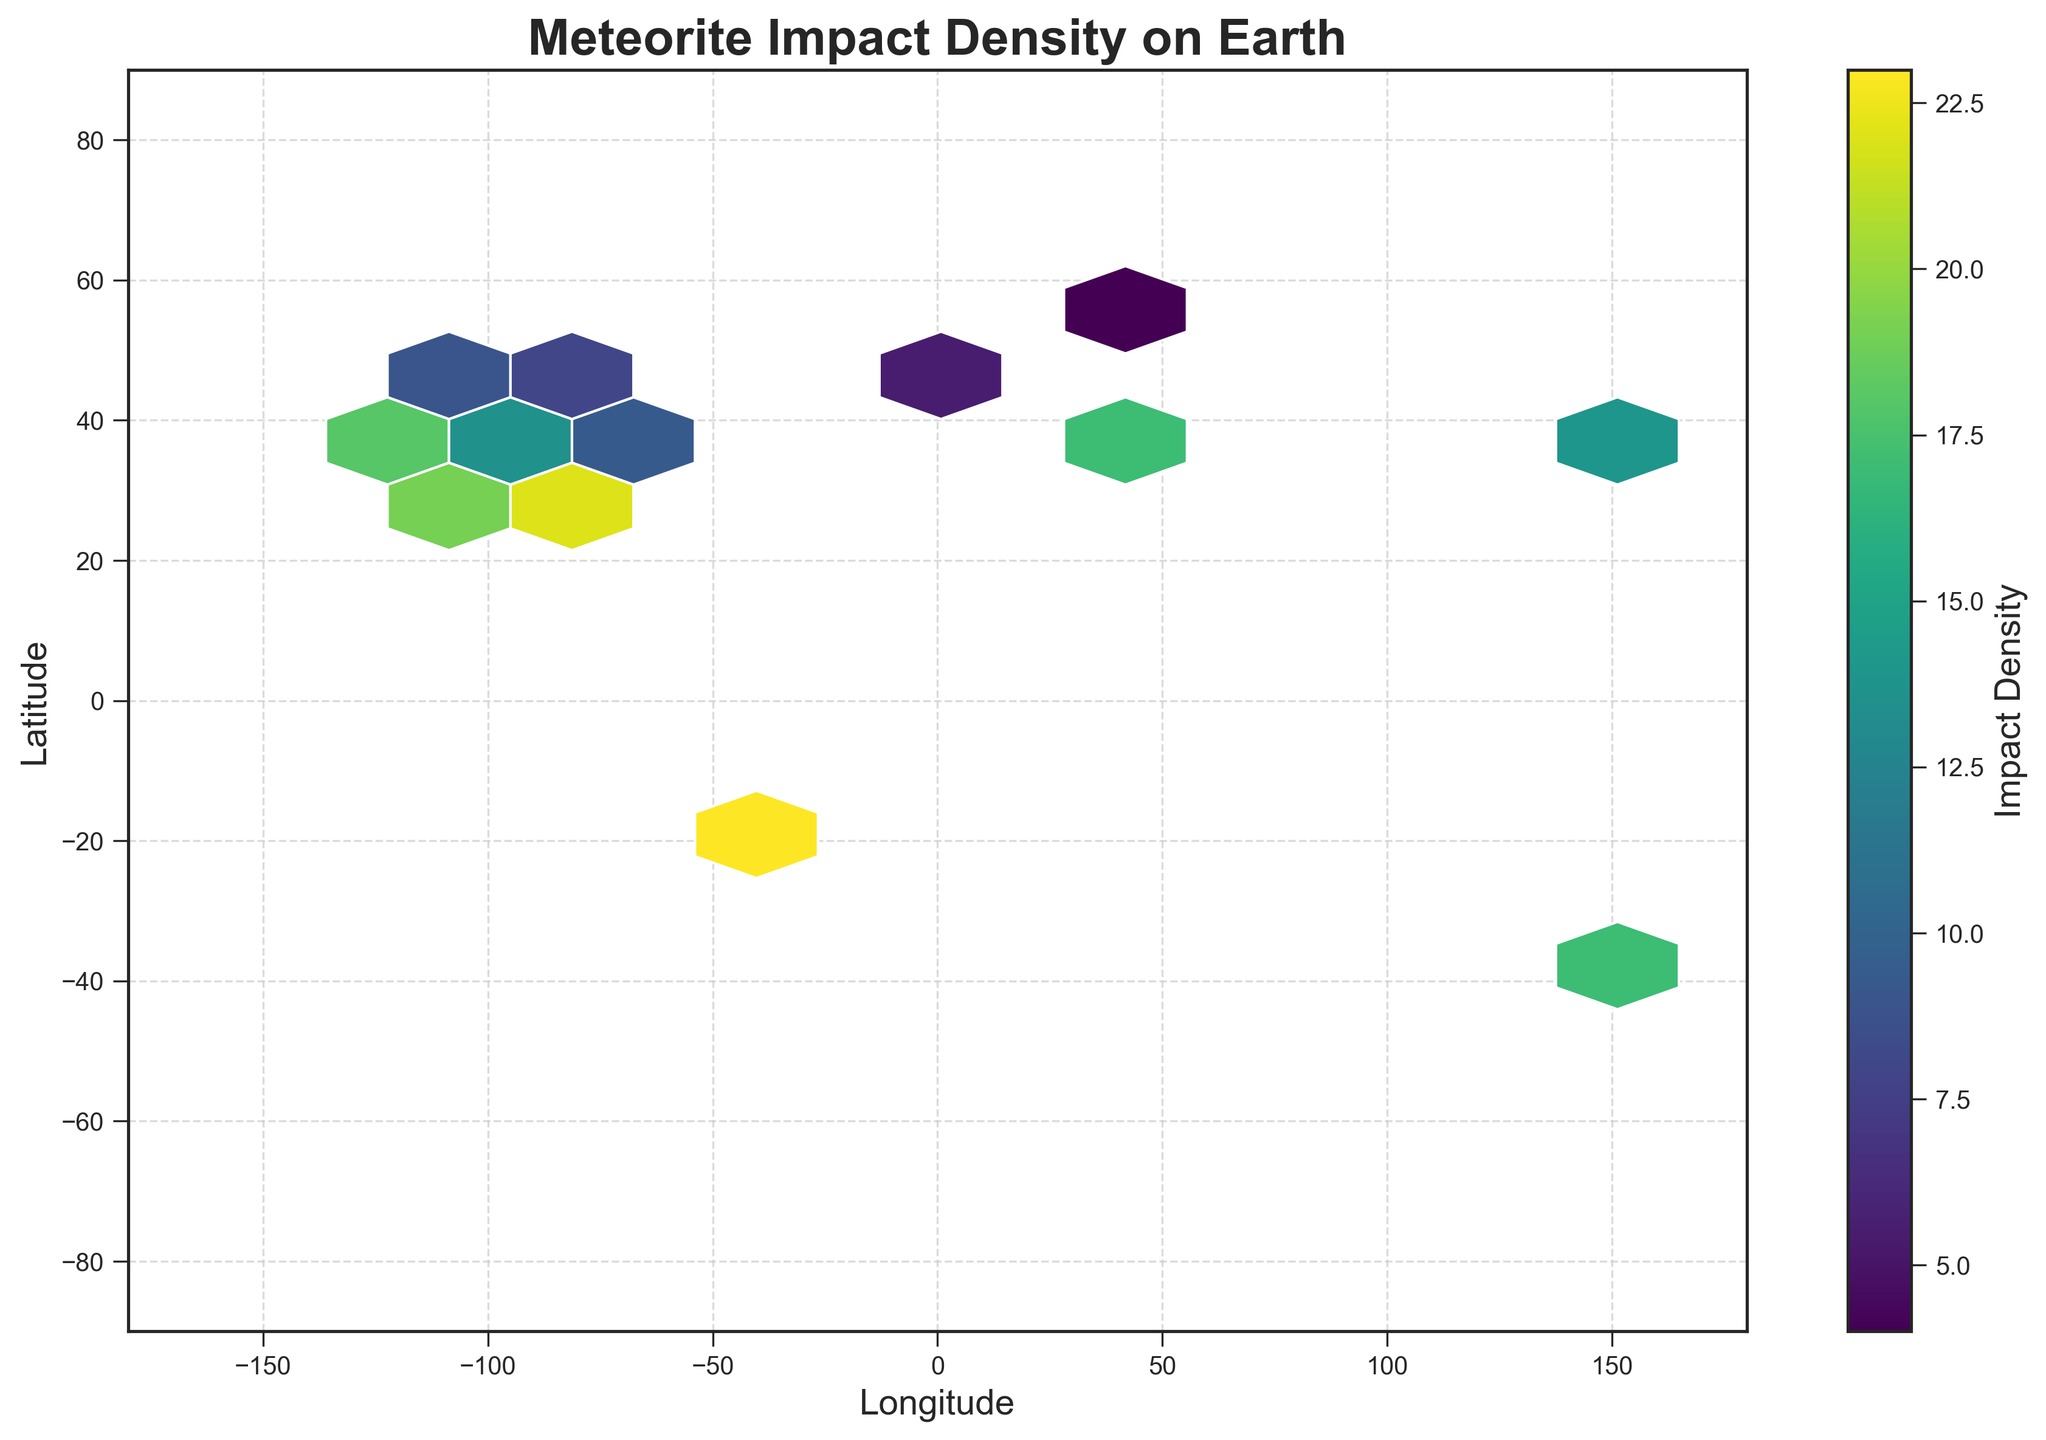What is the title of the figure? The title of the figure is normally displayed at the top of the plot. It provides a brief description of what the figure is illustrating.
Answer: Meteorite Impact Density on Earth What are the ranges of the x-axis and y-axis? The x-axis represents longitude, ranging from -180 to 180 degrees, and the y-axis represents latitude, ranging from -90 to 90 degrees. These ranges are found on the boundaries of the plot.
Answer: x-axis: -180 to 180, y-axis: -90 to 90 Where is the highest density of meteorite impacts located? To find the area with the highest density, look for the hex cells with the darkest color. These cells indicate regions with the highest density of meteorite impacts.
Answer: Around longitude -43, latitude -23 What does the color of the hexagons represent? The color of the hexagons represents meteorite impact density. A colorbar alongside the plot shows how various colors map to different densities.
Answer: Impact density How many data points are there with a latitude between 30 and 40 degrees and a longitude between -120 and -80 degrees? To answer this, locate the grid cells within the specified latitude and longitude ranges and count those hexagons. These regions might include low, medium, and high-density areas, so ensure each is considered.
Answer: 5 What is the trend in meteorite impact density with respect to urban populations? Identify if higher-density areas are located near major urban centers by comparing the locations of darker hex cells with known urban areas. This requires considering geographical knowledge alongside the plot.
Answer: Higher density near major urban centers Is there any significant meteorite impact density near the equator (latitude 0)? Check the hex cells around the equator, latitude 0, and look for color intensity indicating density. No dark hex cells imply low density at the equator.
Answer: No significant density Which hemisphere shows a higher density of meteorite impacts, the Northern or the Southern? Compare the color intensity and number of darker hexagons between the Northern and Southern Hemispheres. This gives a general trend of impact density distribution.
Answer: Southern Hemisphere Between the longitudes of -80 and -120, which latitude range shows the highest density? Look within the specified longitudes, identify all hex cells, and evaluate which latitude range has the most or the darkest hexagons.
Answer: Latitude 25 to 40 degrees Is there any similarity between high-impact-density areas and known meteorite impact sites? Compare known historical meteorite impact sites with high-density regions on the plot to see if they coincide. This is an observational question that connects external knowledge with insights from the plot.
Answer: Likely yes, overlapping in some cases 